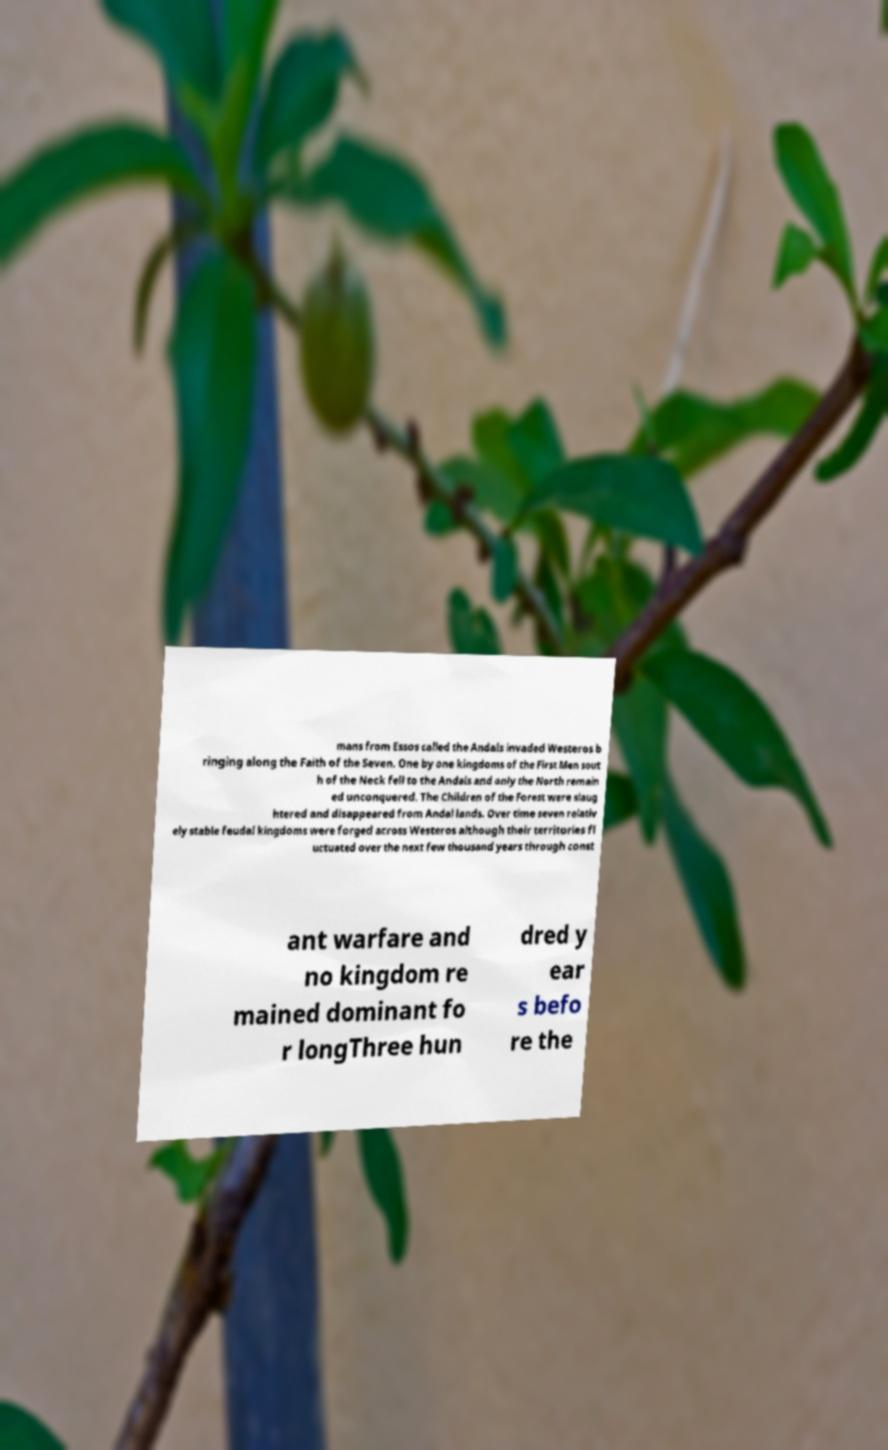Can you read and provide the text displayed in the image?This photo seems to have some interesting text. Can you extract and type it out for me? mans from Essos called the Andals invaded Westeros b ringing along the Faith of the Seven. One by one kingdoms of the First Men sout h of the Neck fell to the Andals and only the North remain ed unconquered. The Children of the Forest were slaug htered and disappeared from Andal lands. Over time seven relativ ely stable feudal kingdoms were forged across Westeros although their territories fl uctuated over the next few thousand years through const ant warfare and no kingdom re mained dominant fo r longThree hun dred y ear s befo re the 